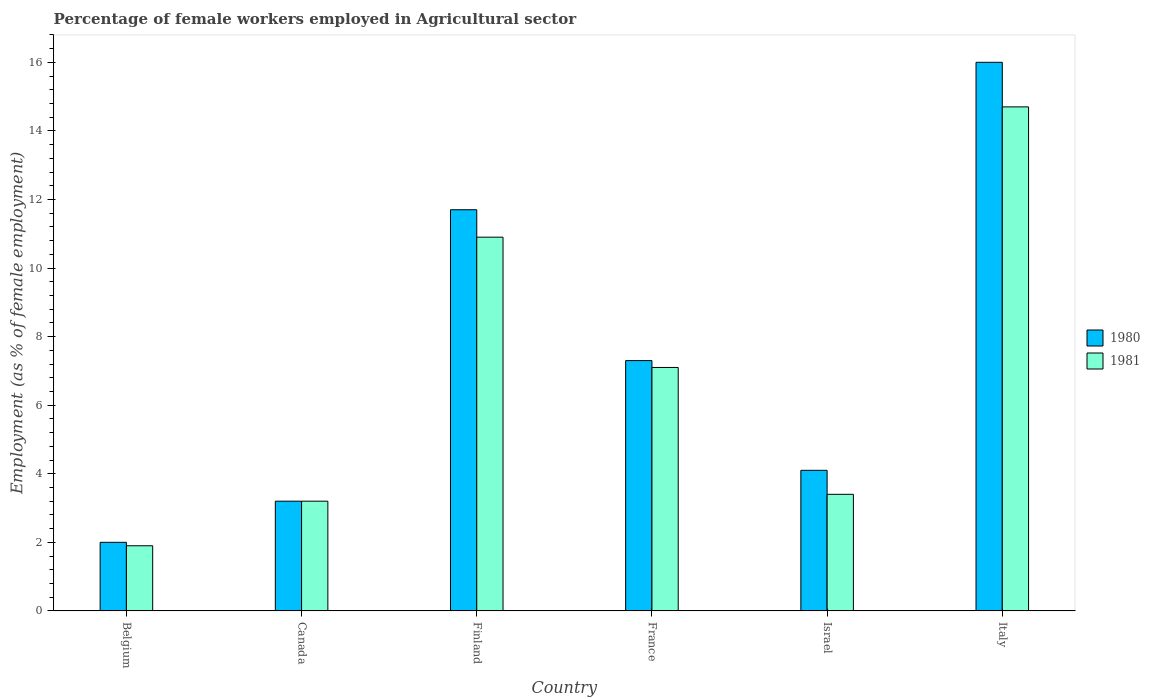Are the number of bars per tick equal to the number of legend labels?
Your response must be concise. Yes. Are the number of bars on each tick of the X-axis equal?
Provide a short and direct response. Yes. What is the label of the 5th group of bars from the left?
Your answer should be very brief. Israel. In how many cases, is the number of bars for a given country not equal to the number of legend labels?
Offer a terse response. 0. What is the percentage of females employed in Agricultural sector in 1981 in Israel?
Ensure brevity in your answer.  3.4. Across all countries, what is the maximum percentage of females employed in Agricultural sector in 1981?
Provide a short and direct response. 14.7. In which country was the percentage of females employed in Agricultural sector in 1981 minimum?
Your response must be concise. Belgium. What is the total percentage of females employed in Agricultural sector in 1981 in the graph?
Make the answer very short. 41.2. What is the difference between the percentage of females employed in Agricultural sector in 1980 in Canada and that in Israel?
Your response must be concise. -0.9. What is the difference between the percentage of females employed in Agricultural sector in 1981 in Israel and the percentage of females employed in Agricultural sector in 1980 in Italy?
Provide a succinct answer. -12.6. What is the average percentage of females employed in Agricultural sector in 1981 per country?
Offer a very short reply. 6.87. What is the difference between the percentage of females employed in Agricultural sector of/in 1981 and percentage of females employed in Agricultural sector of/in 1980 in France?
Offer a terse response. -0.2. In how many countries, is the percentage of females employed in Agricultural sector in 1980 greater than 6.4 %?
Make the answer very short. 3. What is the ratio of the percentage of females employed in Agricultural sector in 1980 in Finland to that in Israel?
Keep it short and to the point. 2.85. What is the difference between the highest and the second highest percentage of females employed in Agricultural sector in 1981?
Provide a short and direct response. -3.8. What is the difference between the highest and the lowest percentage of females employed in Agricultural sector in 1981?
Provide a succinct answer. 12.8. In how many countries, is the percentage of females employed in Agricultural sector in 1981 greater than the average percentage of females employed in Agricultural sector in 1981 taken over all countries?
Give a very brief answer. 3. Are all the bars in the graph horizontal?
Your response must be concise. No. How many countries are there in the graph?
Keep it short and to the point. 6. Does the graph contain any zero values?
Ensure brevity in your answer.  No. Where does the legend appear in the graph?
Your answer should be compact. Center right. How many legend labels are there?
Your answer should be compact. 2. How are the legend labels stacked?
Give a very brief answer. Vertical. What is the title of the graph?
Your response must be concise. Percentage of female workers employed in Agricultural sector. What is the label or title of the Y-axis?
Ensure brevity in your answer.  Employment (as % of female employment). What is the Employment (as % of female employment) of 1981 in Belgium?
Provide a succinct answer. 1.9. What is the Employment (as % of female employment) of 1980 in Canada?
Give a very brief answer. 3.2. What is the Employment (as % of female employment) in 1981 in Canada?
Provide a short and direct response. 3.2. What is the Employment (as % of female employment) in 1980 in Finland?
Offer a terse response. 11.7. What is the Employment (as % of female employment) in 1981 in Finland?
Offer a very short reply. 10.9. What is the Employment (as % of female employment) of 1980 in France?
Your answer should be very brief. 7.3. What is the Employment (as % of female employment) of 1981 in France?
Keep it short and to the point. 7.1. What is the Employment (as % of female employment) in 1980 in Israel?
Give a very brief answer. 4.1. What is the Employment (as % of female employment) of 1981 in Israel?
Offer a very short reply. 3.4. What is the Employment (as % of female employment) in 1981 in Italy?
Offer a terse response. 14.7. Across all countries, what is the maximum Employment (as % of female employment) of 1980?
Provide a succinct answer. 16. Across all countries, what is the maximum Employment (as % of female employment) of 1981?
Give a very brief answer. 14.7. Across all countries, what is the minimum Employment (as % of female employment) in 1981?
Make the answer very short. 1.9. What is the total Employment (as % of female employment) in 1980 in the graph?
Provide a succinct answer. 44.3. What is the total Employment (as % of female employment) in 1981 in the graph?
Provide a succinct answer. 41.2. What is the difference between the Employment (as % of female employment) in 1980 in Belgium and that in Finland?
Offer a terse response. -9.7. What is the difference between the Employment (as % of female employment) of 1980 in Belgium and that in France?
Give a very brief answer. -5.3. What is the difference between the Employment (as % of female employment) in 1981 in Belgium and that in France?
Offer a very short reply. -5.2. What is the difference between the Employment (as % of female employment) in 1980 in Belgium and that in Israel?
Your response must be concise. -2.1. What is the difference between the Employment (as % of female employment) of 1981 in Belgium and that in Israel?
Offer a very short reply. -1.5. What is the difference between the Employment (as % of female employment) of 1980 in Belgium and that in Italy?
Offer a very short reply. -14. What is the difference between the Employment (as % of female employment) of 1981 in Canada and that in Finland?
Offer a very short reply. -7.7. What is the difference between the Employment (as % of female employment) of 1981 in Canada and that in Israel?
Offer a terse response. -0.2. What is the difference between the Employment (as % of female employment) of 1981 in Finland and that in France?
Make the answer very short. 3.8. What is the difference between the Employment (as % of female employment) in 1980 in Finland and that in Israel?
Make the answer very short. 7.6. What is the difference between the Employment (as % of female employment) of 1980 in Finland and that in Italy?
Provide a short and direct response. -4.3. What is the difference between the Employment (as % of female employment) in 1980 in France and that in Israel?
Your answer should be very brief. 3.2. What is the difference between the Employment (as % of female employment) of 1980 in Israel and that in Italy?
Make the answer very short. -11.9. What is the difference between the Employment (as % of female employment) of 1980 in Belgium and the Employment (as % of female employment) of 1981 in Canada?
Your response must be concise. -1.2. What is the difference between the Employment (as % of female employment) of 1980 in Belgium and the Employment (as % of female employment) of 1981 in France?
Offer a terse response. -5.1. What is the difference between the Employment (as % of female employment) in 1980 in Belgium and the Employment (as % of female employment) in 1981 in Israel?
Provide a succinct answer. -1.4. What is the difference between the Employment (as % of female employment) in 1980 in Belgium and the Employment (as % of female employment) in 1981 in Italy?
Your response must be concise. -12.7. What is the difference between the Employment (as % of female employment) of 1980 in Canada and the Employment (as % of female employment) of 1981 in Finland?
Give a very brief answer. -7.7. What is the difference between the Employment (as % of female employment) of 1980 in Canada and the Employment (as % of female employment) of 1981 in France?
Keep it short and to the point. -3.9. What is the difference between the Employment (as % of female employment) in 1980 in Canada and the Employment (as % of female employment) in 1981 in Israel?
Offer a very short reply. -0.2. What is the difference between the Employment (as % of female employment) of 1980 in Canada and the Employment (as % of female employment) of 1981 in Italy?
Your response must be concise. -11.5. What is the difference between the Employment (as % of female employment) of 1980 in France and the Employment (as % of female employment) of 1981 in Israel?
Your answer should be very brief. 3.9. What is the average Employment (as % of female employment) in 1980 per country?
Your answer should be compact. 7.38. What is the average Employment (as % of female employment) of 1981 per country?
Provide a succinct answer. 6.87. What is the difference between the Employment (as % of female employment) of 1980 and Employment (as % of female employment) of 1981 in Canada?
Provide a short and direct response. 0. What is the difference between the Employment (as % of female employment) in 1980 and Employment (as % of female employment) in 1981 in Israel?
Make the answer very short. 0.7. What is the ratio of the Employment (as % of female employment) of 1980 in Belgium to that in Canada?
Provide a short and direct response. 0.62. What is the ratio of the Employment (as % of female employment) in 1981 in Belgium to that in Canada?
Ensure brevity in your answer.  0.59. What is the ratio of the Employment (as % of female employment) in 1980 in Belgium to that in Finland?
Your response must be concise. 0.17. What is the ratio of the Employment (as % of female employment) in 1981 in Belgium to that in Finland?
Ensure brevity in your answer.  0.17. What is the ratio of the Employment (as % of female employment) of 1980 in Belgium to that in France?
Your answer should be very brief. 0.27. What is the ratio of the Employment (as % of female employment) of 1981 in Belgium to that in France?
Your answer should be very brief. 0.27. What is the ratio of the Employment (as % of female employment) in 1980 in Belgium to that in Israel?
Offer a very short reply. 0.49. What is the ratio of the Employment (as % of female employment) in 1981 in Belgium to that in Israel?
Your answer should be compact. 0.56. What is the ratio of the Employment (as % of female employment) in 1980 in Belgium to that in Italy?
Keep it short and to the point. 0.12. What is the ratio of the Employment (as % of female employment) in 1981 in Belgium to that in Italy?
Provide a succinct answer. 0.13. What is the ratio of the Employment (as % of female employment) of 1980 in Canada to that in Finland?
Give a very brief answer. 0.27. What is the ratio of the Employment (as % of female employment) in 1981 in Canada to that in Finland?
Your answer should be compact. 0.29. What is the ratio of the Employment (as % of female employment) in 1980 in Canada to that in France?
Give a very brief answer. 0.44. What is the ratio of the Employment (as % of female employment) in 1981 in Canada to that in France?
Offer a very short reply. 0.45. What is the ratio of the Employment (as % of female employment) in 1980 in Canada to that in Israel?
Offer a terse response. 0.78. What is the ratio of the Employment (as % of female employment) in 1981 in Canada to that in Italy?
Provide a succinct answer. 0.22. What is the ratio of the Employment (as % of female employment) of 1980 in Finland to that in France?
Give a very brief answer. 1.6. What is the ratio of the Employment (as % of female employment) in 1981 in Finland to that in France?
Make the answer very short. 1.54. What is the ratio of the Employment (as % of female employment) in 1980 in Finland to that in Israel?
Keep it short and to the point. 2.85. What is the ratio of the Employment (as % of female employment) in 1981 in Finland to that in Israel?
Give a very brief answer. 3.21. What is the ratio of the Employment (as % of female employment) in 1980 in Finland to that in Italy?
Your response must be concise. 0.73. What is the ratio of the Employment (as % of female employment) of 1981 in Finland to that in Italy?
Give a very brief answer. 0.74. What is the ratio of the Employment (as % of female employment) of 1980 in France to that in Israel?
Your response must be concise. 1.78. What is the ratio of the Employment (as % of female employment) of 1981 in France to that in Israel?
Your answer should be very brief. 2.09. What is the ratio of the Employment (as % of female employment) in 1980 in France to that in Italy?
Provide a short and direct response. 0.46. What is the ratio of the Employment (as % of female employment) in 1981 in France to that in Italy?
Ensure brevity in your answer.  0.48. What is the ratio of the Employment (as % of female employment) of 1980 in Israel to that in Italy?
Your answer should be very brief. 0.26. What is the ratio of the Employment (as % of female employment) of 1981 in Israel to that in Italy?
Keep it short and to the point. 0.23. What is the difference between the highest and the second highest Employment (as % of female employment) of 1981?
Ensure brevity in your answer.  3.8. What is the difference between the highest and the lowest Employment (as % of female employment) in 1980?
Give a very brief answer. 14. 